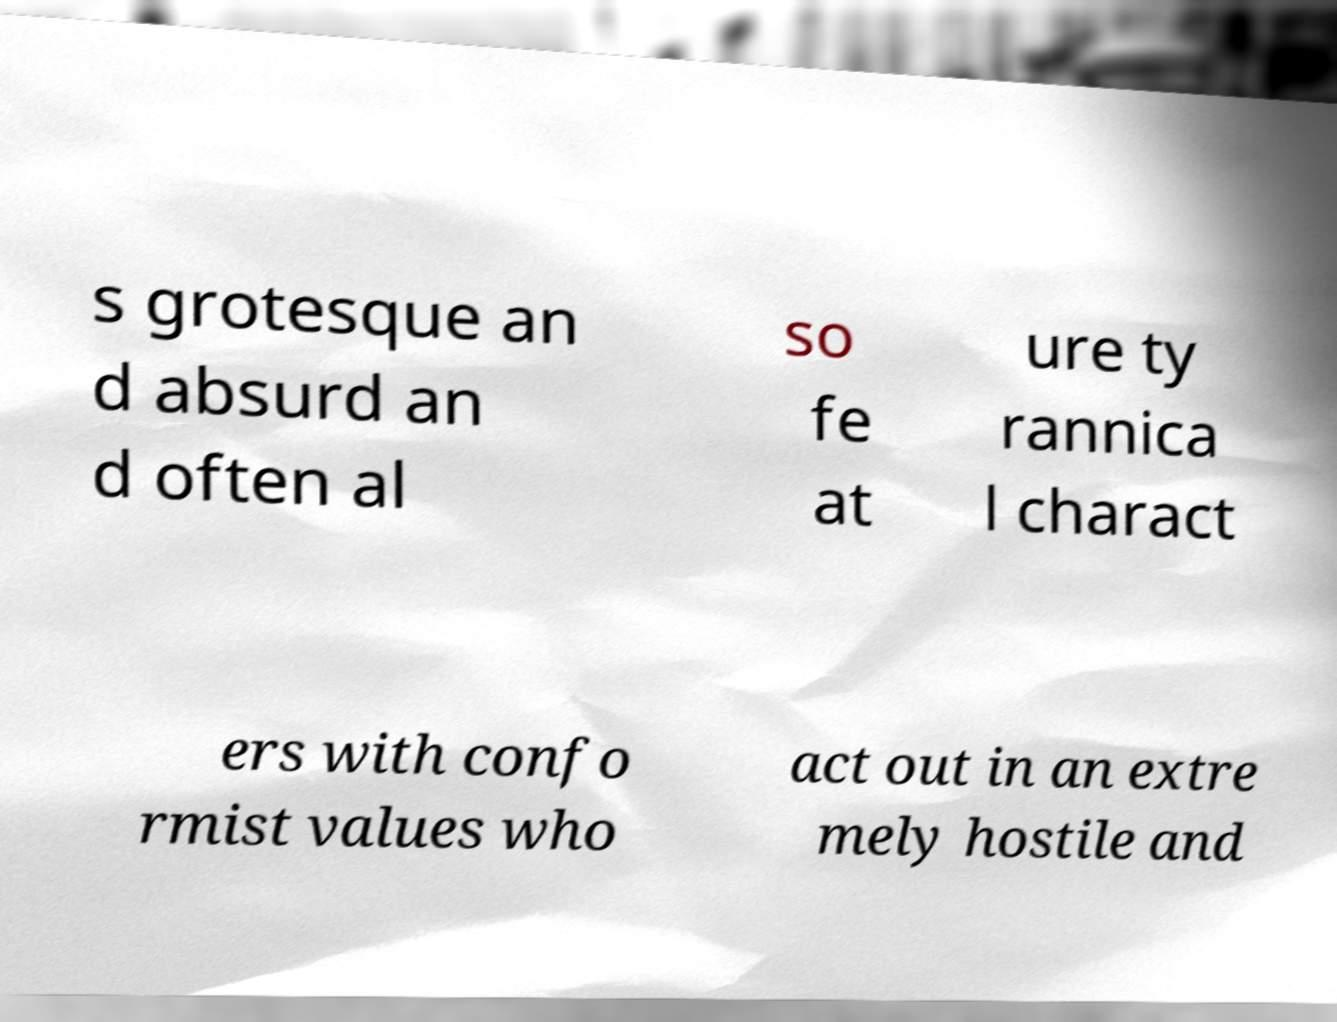Can you accurately transcribe the text from the provided image for me? s grotesque an d absurd an d often al so fe at ure ty rannica l charact ers with confo rmist values who act out in an extre mely hostile and 